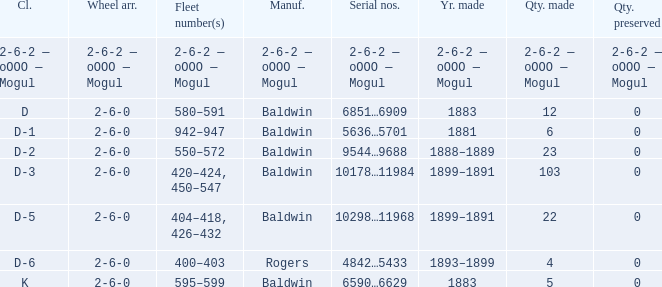What is the quantity made when the class is d-2? 23.0. 